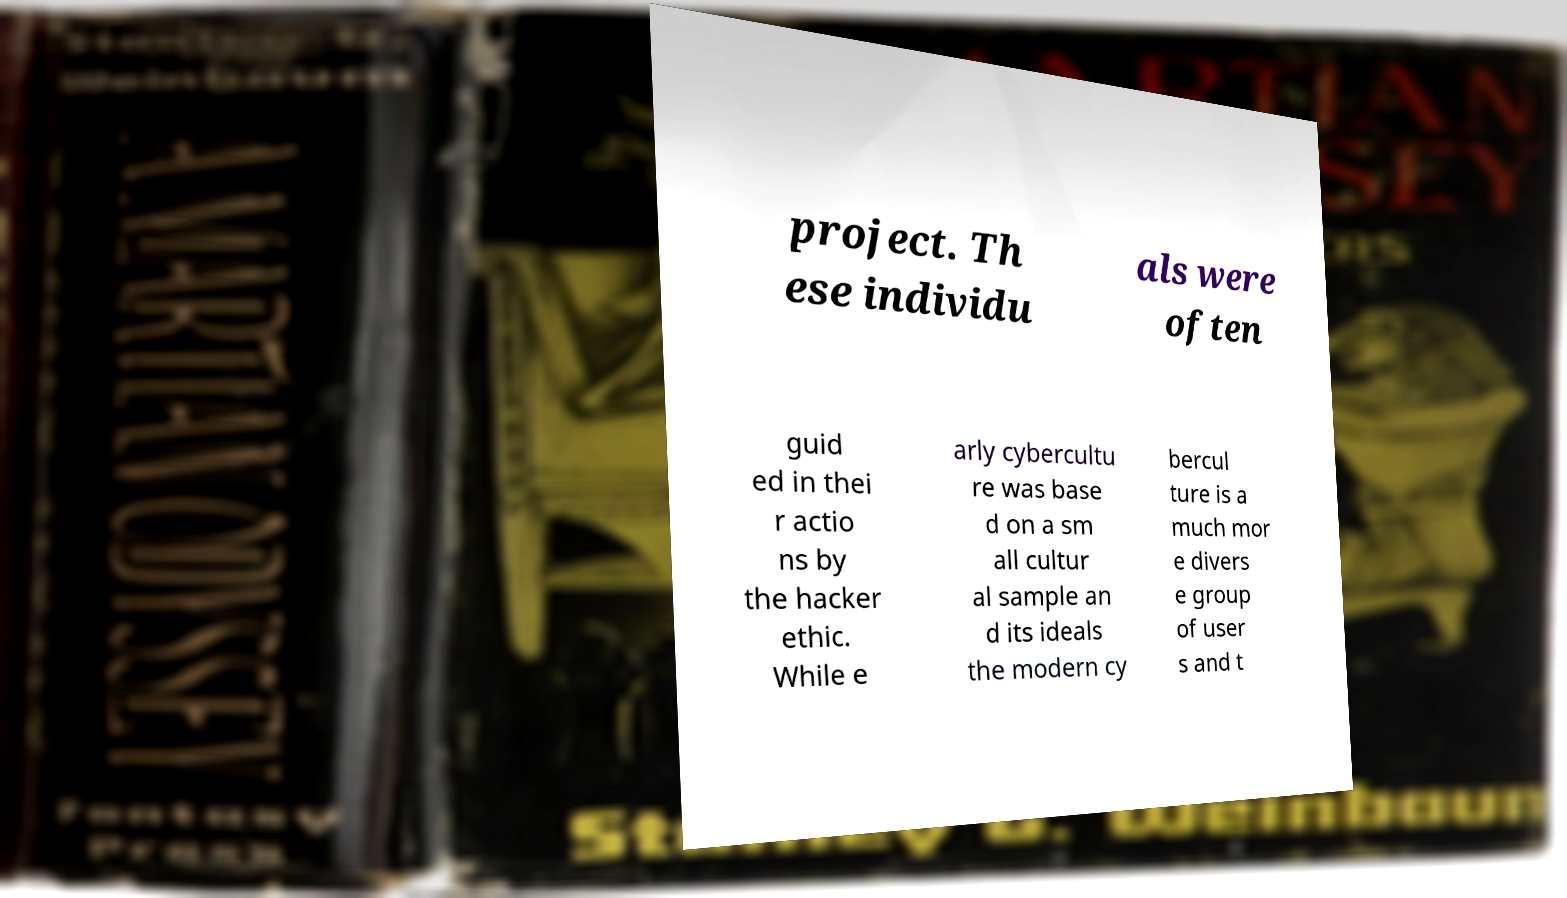Please read and relay the text visible in this image. What does it say? project. Th ese individu als were often guid ed in thei r actio ns by the hacker ethic. While e arly cybercultu re was base d on a sm all cultur al sample an d its ideals the modern cy bercul ture is a much mor e divers e group of user s and t 